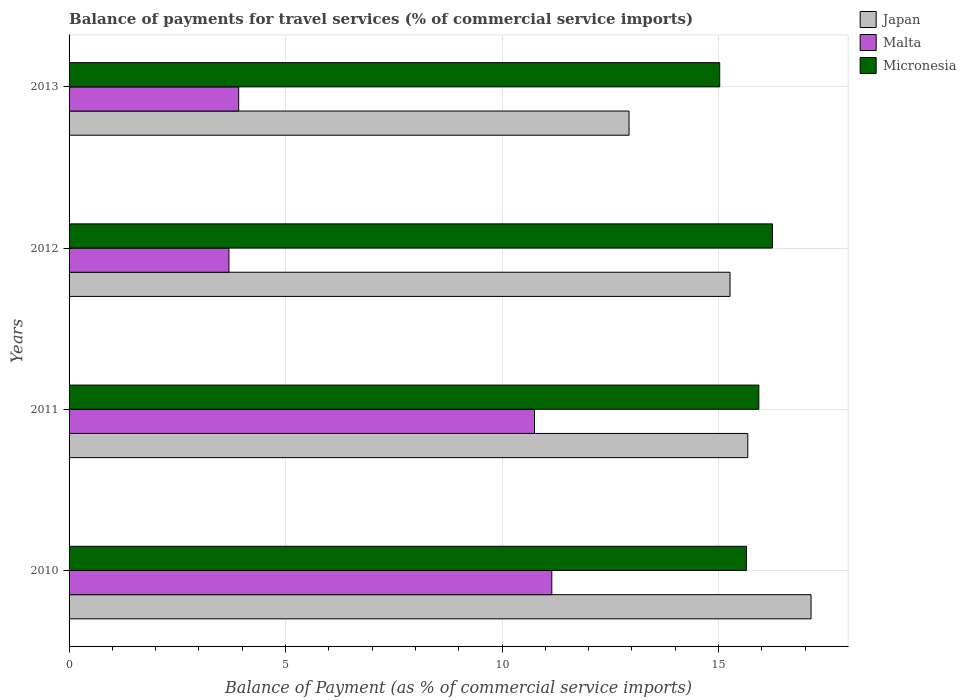How many different coloured bars are there?
Your answer should be very brief. 3. How many groups of bars are there?
Offer a terse response. 4. Are the number of bars per tick equal to the number of legend labels?
Your response must be concise. Yes. How many bars are there on the 2nd tick from the top?
Give a very brief answer. 3. How many bars are there on the 2nd tick from the bottom?
Your answer should be very brief. 3. What is the balance of payments for travel services in Micronesia in 2011?
Your answer should be very brief. 15.93. Across all years, what is the maximum balance of payments for travel services in Malta?
Provide a succinct answer. 11.15. Across all years, what is the minimum balance of payments for travel services in Micronesia?
Your answer should be very brief. 15.03. In which year was the balance of payments for travel services in Japan minimum?
Ensure brevity in your answer.  2013. What is the total balance of payments for travel services in Japan in the graph?
Make the answer very short. 61.01. What is the difference between the balance of payments for travel services in Malta in 2010 and that in 2012?
Offer a terse response. 7.46. What is the difference between the balance of payments for travel services in Malta in 2010 and the balance of payments for travel services in Micronesia in 2012?
Your answer should be very brief. -5.09. What is the average balance of payments for travel services in Micronesia per year?
Your answer should be compact. 15.71. In the year 2011, what is the difference between the balance of payments for travel services in Malta and balance of payments for travel services in Micronesia?
Keep it short and to the point. -5.18. In how many years, is the balance of payments for travel services in Malta greater than 10 %?
Offer a terse response. 2. What is the ratio of the balance of payments for travel services in Malta in 2010 to that in 2012?
Offer a terse response. 3.02. Is the balance of payments for travel services in Malta in 2012 less than that in 2013?
Your answer should be very brief. Yes. What is the difference between the highest and the second highest balance of payments for travel services in Malta?
Keep it short and to the point. 0.4. What is the difference between the highest and the lowest balance of payments for travel services in Japan?
Offer a very short reply. 4.2. In how many years, is the balance of payments for travel services in Malta greater than the average balance of payments for travel services in Malta taken over all years?
Your answer should be very brief. 2. Is the sum of the balance of payments for travel services in Micronesia in 2010 and 2011 greater than the maximum balance of payments for travel services in Malta across all years?
Provide a short and direct response. Yes. What does the 2nd bar from the top in 2010 represents?
Offer a very short reply. Malta. What does the 3rd bar from the bottom in 2013 represents?
Offer a terse response. Micronesia. How many bars are there?
Keep it short and to the point. 12. Are all the bars in the graph horizontal?
Your response must be concise. Yes. How many years are there in the graph?
Ensure brevity in your answer.  4. What is the difference between two consecutive major ticks on the X-axis?
Offer a terse response. 5. Are the values on the major ticks of X-axis written in scientific E-notation?
Keep it short and to the point. No. Does the graph contain any zero values?
Offer a very short reply. No. Where does the legend appear in the graph?
Your answer should be very brief. Top right. What is the title of the graph?
Ensure brevity in your answer.  Balance of payments for travel services (% of commercial service imports). Does "Europe(developing only)" appear as one of the legend labels in the graph?
Provide a short and direct response. No. What is the label or title of the X-axis?
Provide a succinct answer. Balance of Payment (as % of commercial service imports). What is the label or title of the Y-axis?
Provide a short and direct response. Years. What is the Balance of Payment (as % of commercial service imports) in Japan in 2010?
Your answer should be compact. 17.14. What is the Balance of Payment (as % of commercial service imports) in Malta in 2010?
Offer a very short reply. 11.15. What is the Balance of Payment (as % of commercial service imports) in Micronesia in 2010?
Provide a succinct answer. 15.64. What is the Balance of Payment (as % of commercial service imports) in Japan in 2011?
Your answer should be compact. 15.67. What is the Balance of Payment (as % of commercial service imports) in Malta in 2011?
Your response must be concise. 10.75. What is the Balance of Payment (as % of commercial service imports) of Micronesia in 2011?
Your answer should be very brief. 15.93. What is the Balance of Payment (as % of commercial service imports) of Japan in 2012?
Your answer should be compact. 15.26. What is the Balance of Payment (as % of commercial service imports) of Malta in 2012?
Offer a very short reply. 3.69. What is the Balance of Payment (as % of commercial service imports) in Micronesia in 2012?
Your answer should be compact. 16.24. What is the Balance of Payment (as % of commercial service imports) of Japan in 2013?
Give a very brief answer. 12.93. What is the Balance of Payment (as % of commercial service imports) in Malta in 2013?
Ensure brevity in your answer.  3.92. What is the Balance of Payment (as % of commercial service imports) of Micronesia in 2013?
Your answer should be compact. 15.03. Across all years, what is the maximum Balance of Payment (as % of commercial service imports) of Japan?
Provide a succinct answer. 17.14. Across all years, what is the maximum Balance of Payment (as % of commercial service imports) in Malta?
Give a very brief answer. 11.15. Across all years, what is the maximum Balance of Payment (as % of commercial service imports) in Micronesia?
Ensure brevity in your answer.  16.24. Across all years, what is the minimum Balance of Payment (as % of commercial service imports) in Japan?
Give a very brief answer. 12.93. Across all years, what is the minimum Balance of Payment (as % of commercial service imports) of Malta?
Offer a very short reply. 3.69. Across all years, what is the minimum Balance of Payment (as % of commercial service imports) in Micronesia?
Your answer should be compact. 15.03. What is the total Balance of Payment (as % of commercial service imports) of Japan in the graph?
Provide a short and direct response. 61.01. What is the total Balance of Payment (as % of commercial service imports) in Malta in the graph?
Provide a short and direct response. 29.51. What is the total Balance of Payment (as % of commercial service imports) of Micronesia in the graph?
Keep it short and to the point. 62.84. What is the difference between the Balance of Payment (as % of commercial service imports) of Japan in 2010 and that in 2011?
Provide a succinct answer. 1.46. What is the difference between the Balance of Payment (as % of commercial service imports) of Malta in 2010 and that in 2011?
Offer a terse response. 0.4. What is the difference between the Balance of Payment (as % of commercial service imports) of Micronesia in 2010 and that in 2011?
Your answer should be compact. -0.29. What is the difference between the Balance of Payment (as % of commercial service imports) of Japan in 2010 and that in 2012?
Ensure brevity in your answer.  1.87. What is the difference between the Balance of Payment (as % of commercial service imports) in Malta in 2010 and that in 2012?
Give a very brief answer. 7.46. What is the difference between the Balance of Payment (as % of commercial service imports) in Micronesia in 2010 and that in 2012?
Your response must be concise. -0.6. What is the difference between the Balance of Payment (as % of commercial service imports) in Japan in 2010 and that in 2013?
Ensure brevity in your answer.  4.2. What is the difference between the Balance of Payment (as % of commercial service imports) of Malta in 2010 and that in 2013?
Your answer should be very brief. 7.23. What is the difference between the Balance of Payment (as % of commercial service imports) of Micronesia in 2010 and that in 2013?
Make the answer very short. 0.62. What is the difference between the Balance of Payment (as % of commercial service imports) in Japan in 2011 and that in 2012?
Make the answer very short. 0.41. What is the difference between the Balance of Payment (as % of commercial service imports) in Malta in 2011 and that in 2012?
Offer a very short reply. 7.06. What is the difference between the Balance of Payment (as % of commercial service imports) of Micronesia in 2011 and that in 2012?
Provide a short and direct response. -0.31. What is the difference between the Balance of Payment (as % of commercial service imports) in Japan in 2011 and that in 2013?
Your answer should be very brief. 2.74. What is the difference between the Balance of Payment (as % of commercial service imports) in Malta in 2011 and that in 2013?
Provide a succinct answer. 6.83. What is the difference between the Balance of Payment (as % of commercial service imports) of Micronesia in 2011 and that in 2013?
Ensure brevity in your answer.  0.9. What is the difference between the Balance of Payment (as % of commercial service imports) of Japan in 2012 and that in 2013?
Make the answer very short. 2.33. What is the difference between the Balance of Payment (as % of commercial service imports) of Malta in 2012 and that in 2013?
Provide a succinct answer. -0.23. What is the difference between the Balance of Payment (as % of commercial service imports) in Micronesia in 2012 and that in 2013?
Your response must be concise. 1.22. What is the difference between the Balance of Payment (as % of commercial service imports) in Japan in 2010 and the Balance of Payment (as % of commercial service imports) in Malta in 2011?
Make the answer very short. 6.39. What is the difference between the Balance of Payment (as % of commercial service imports) in Japan in 2010 and the Balance of Payment (as % of commercial service imports) in Micronesia in 2011?
Provide a succinct answer. 1.21. What is the difference between the Balance of Payment (as % of commercial service imports) of Malta in 2010 and the Balance of Payment (as % of commercial service imports) of Micronesia in 2011?
Your answer should be very brief. -4.78. What is the difference between the Balance of Payment (as % of commercial service imports) in Japan in 2010 and the Balance of Payment (as % of commercial service imports) in Malta in 2012?
Offer a terse response. 13.44. What is the difference between the Balance of Payment (as % of commercial service imports) in Japan in 2010 and the Balance of Payment (as % of commercial service imports) in Micronesia in 2012?
Give a very brief answer. 0.89. What is the difference between the Balance of Payment (as % of commercial service imports) of Malta in 2010 and the Balance of Payment (as % of commercial service imports) of Micronesia in 2012?
Your answer should be very brief. -5.09. What is the difference between the Balance of Payment (as % of commercial service imports) of Japan in 2010 and the Balance of Payment (as % of commercial service imports) of Malta in 2013?
Your answer should be very brief. 13.22. What is the difference between the Balance of Payment (as % of commercial service imports) in Japan in 2010 and the Balance of Payment (as % of commercial service imports) in Micronesia in 2013?
Keep it short and to the point. 2.11. What is the difference between the Balance of Payment (as % of commercial service imports) of Malta in 2010 and the Balance of Payment (as % of commercial service imports) of Micronesia in 2013?
Keep it short and to the point. -3.88. What is the difference between the Balance of Payment (as % of commercial service imports) of Japan in 2011 and the Balance of Payment (as % of commercial service imports) of Malta in 2012?
Offer a terse response. 11.98. What is the difference between the Balance of Payment (as % of commercial service imports) in Japan in 2011 and the Balance of Payment (as % of commercial service imports) in Micronesia in 2012?
Make the answer very short. -0.57. What is the difference between the Balance of Payment (as % of commercial service imports) of Malta in 2011 and the Balance of Payment (as % of commercial service imports) of Micronesia in 2012?
Your answer should be very brief. -5.49. What is the difference between the Balance of Payment (as % of commercial service imports) in Japan in 2011 and the Balance of Payment (as % of commercial service imports) in Malta in 2013?
Ensure brevity in your answer.  11.76. What is the difference between the Balance of Payment (as % of commercial service imports) of Japan in 2011 and the Balance of Payment (as % of commercial service imports) of Micronesia in 2013?
Offer a very short reply. 0.65. What is the difference between the Balance of Payment (as % of commercial service imports) of Malta in 2011 and the Balance of Payment (as % of commercial service imports) of Micronesia in 2013?
Your response must be concise. -4.28. What is the difference between the Balance of Payment (as % of commercial service imports) in Japan in 2012 and the Balance of Payment (as % of commercial service imports) in Malta in 2013?
Provide a short and direct response. 11.35. What is the difference between the Balance of Payment (as % of commercial service imports) of Japan in 2012 and the Balance of Payment (as % of commercial service imports) of Micronesia in 2013?
Your response must be concise. 0.24. What is the difference between the Balance of Payment (as % of commercial service imports) in Malta in 2012 and the Balance of Payment (as % of commercial service imports) in Micronesia in 2013?
Keep it short and to the point. -11.33. What is the average Balance of Payment (as % of commercial service imports) of Japan per year?
Provide a short and direct response. 15.25. What is the average Balance of Payment (as % of commercial service imports) in Malta per year?
Provide a succinct answer. 7.38. What is the average Balance of Payment (as % of commercial service imports) in Micronesia per year?
Your answer should be compact. 15.71. In the year 2010, what is the difference between the Balance of Payment (as % of commercial service imports) in Japan and Balance of Payment (as % of commercial service imports) in Malta?
Your response must be concise. 5.99. In the year 2010, what is the difference between the Balance of Payment (as % of commercial service imports) in Japan and Balance of Payment (as % of commercial service imports) in Micronesia?
Your answer should be very brief. 1.49. In the year 2010, what is the difference between the Balance of Payment (as % of commercial service imports) of Malta and Balance of Payment (as % of commercial service imports) of Micronesia?
Your response must be concise. -4.49. In the year 2011, what is the difference between the Balance of Payment (as % of commercial service imports) of Japan and Balance of Payment (as % of commercial service imports) of Malta?
Offer a terse response. 4.93. In the year 2011, what is the difference between the Balance of Payment (as % of commercial service imports) of Japan and Balance of Payment (as % of commercial service imports) of Micronesia?
Your answer should be very brief. -0.26. In the year 2011, what is the difference between the Balance of Payment (as % of commercial service imports) of Malta and Balance of Payment (as % of commercial service imports) of Micronesia?
Offer a very short reply. -5.18. In the year 2012, what is the difference between the Balance of Payment (as % of commercial service imports) in Japan and Balance of Payment (as % of commercial service imports) in Malta?
Provide a succinct answer. 11.57. In the year 2012, what is the difference between the Balance of Payment (as % of commercial service imports) in Japan and Balance of Payment (as % of commercial service imports) in Micronesia?
Your response must be concise. -0.98. In the year 2012, what is the difference between the Balance of Payment (as % of commercial service imports) of Malta and Balance of Payment (as % of commercial service imports) of Micronesia?
Make the answer very short. -12.55. In the year 2013, what is the difference between the Balance of Payment (as % of commercial service imports) in Japan and Balance of Payment (as % of commercial service imports) in Malta?
Keep it short and to the point. 9.02. In the year 2013, what is the difference between the Balance of Payment (as % of commercial service imports) in Japan and Balance of Payment (as % of commercial service imports) in Micronesia?
Keep it short and to the point. -2.09. In the year 2013, what is the difference between the Balance of Payment (as % of commercial service imports) in Malta and Balance of Payment (as % of commercial service imports) in Micronesia?
Keep it short and to the point. -11.11. What is the ratio of the Balance of Payment (as % of commercial service imports) of Japan in 2010 to that in 2011?
Provide a succinct answer. 1.09. What is the ratio of the Balance of Payment (as % of commercial service imports) of Malta in 2010 to that in 2011?
Make the answer very short. 1.04. What is the ratio of the Balance of Payment (as % of commercial service imports) of Micronesia in 2010 to that in 2011?
Offer a terse response. 0.98. What is the ratio of the Balance of Payment (as % of commercial service imports) in Japan in 2010 to that in 2012?
Make the answer very short. 1.12. What is the ratio of the Balance of Payment (as % of commercial service imports) in Malta in 2010 to that in 2012?
Offer a very short reply. 3.02. What is the ratio of the Balance of Payment (as % of commercial service imports) in Micronesia in 2010 to that in 2012?
Give a very brief answer. 0.96. What is the ratio of the Balance of Payment (as % of commercial service imports) in Japan in 2010 to that in 2013?
Provide a short and direct response. 1.33. What is the ratio of the Balance of Payment (as % of commercial service imports) in Malta in 2010 to that in 2013?
Give a very brief answer. 2.85. What is the ratio of the Balance of Payment (as % of commercial service imports) of Micronesia in 2010 to that in 2013?
Ensure brevity in your answer.  1.04. What is the ratio of the Balance of Payment (as % of commercial service imports) in Japan in 2011 to that in 2012?
Your answer should be compact. 1.03. What is the ratio of the Balance of Payment (as % of commercial service imports) in Malta in 2011 to that in 2012?
Keep it short and to the point. 2.91. What is the ratio of the Balance of Payment (as % of commercial service imports) of Micronesia in 2011 to that in 2012?
Ensure brevity in your answer.  0.98. What is the ratio of the Balance of Payment (as % of commercial service imports) of Japan in 2011 to that in 2013?
Provide a succinct answer. 1.21. What is the ratio of the Balance of Payment (as % of commercial service imports) in Malta in 2011 to that in 2013?
Keep it short and to the point. 2.74. What is the ratio of the Balance of Payment (as % of commercial service imports) of Micronesia in 2011 to that in 2013?
Make the answer very short. 1.06. What is the ratio of the Balance of Payment (as % of commercial service imports) of Japan in 2012 to that in 2013?
Make the answer very short. 1.18. What is the ratio of the Balance of Payment (as % of commercial service imports) in Malta in 2012 to that in 2013?
Provide a succinct answer. 0.94. What is the ratio of the Balance of Payment (as % of commercial service imports) of Micronesia in 2012 to that in 2013?
Offer a terse response. 1.08. What is the difference between the highest and the second highest Balance of Payment (as % of commercial service imports) in Japan?
Keep it short and to the point. 1.46. What is the difference between the highest and the second highest Balance of Payment (as % of commercial service imports) of Malta?
Give a very brief answer. 0.4. What is the difference between the highest and the second highest Balance of Payment (as % of commercial service imports) of Micronesia?
Provide a succinct answer. 0.31. What is the difference between the highest and the lowest Balance of Payment (as % of commercial service imports) in Japan?
Provide a succinct answer. 4.2. What is the difference between the highest and the lowest Balance of Payment (as % of commercial service imports) in Malta?
Give a very brief answer. 7.46. What is the difference between the highest and the lowest Balance of Payment (as % of commercial service imports) of Micronesia?
Your response must be concise. 1.22. 